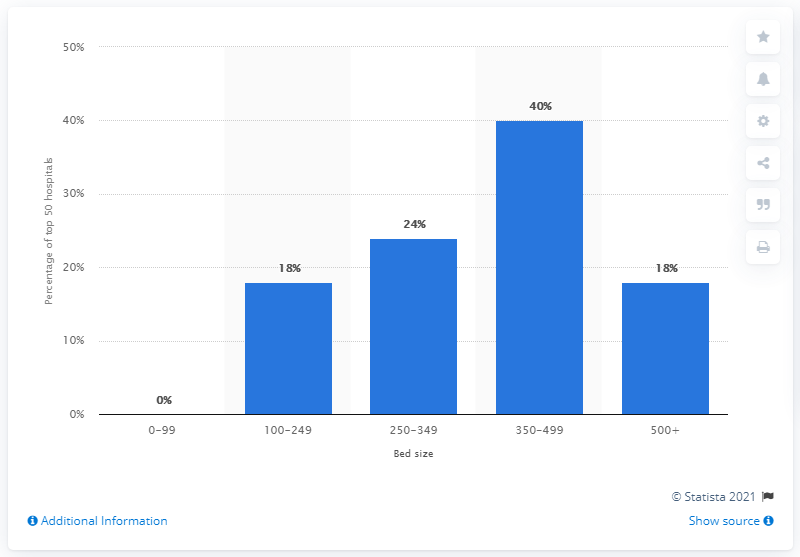Outline some significant characteristics in this image. In 2011, a significant percentage of the top 50 hospitals in the United States had between 100 and 249 patient beds. Specifically, 18% of these hospitals fell within this bed capacity range. 